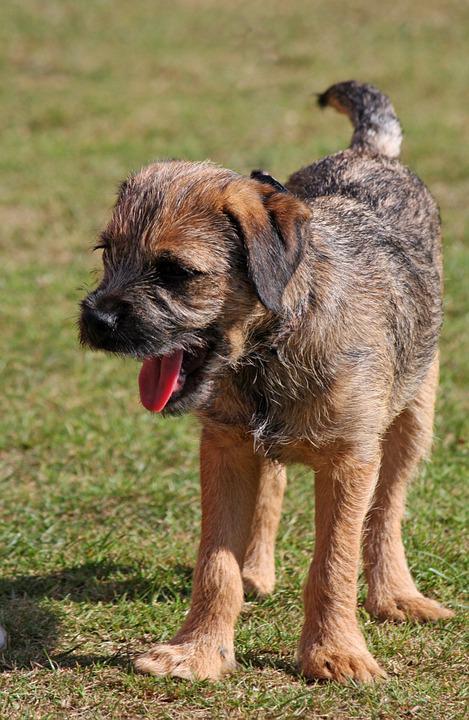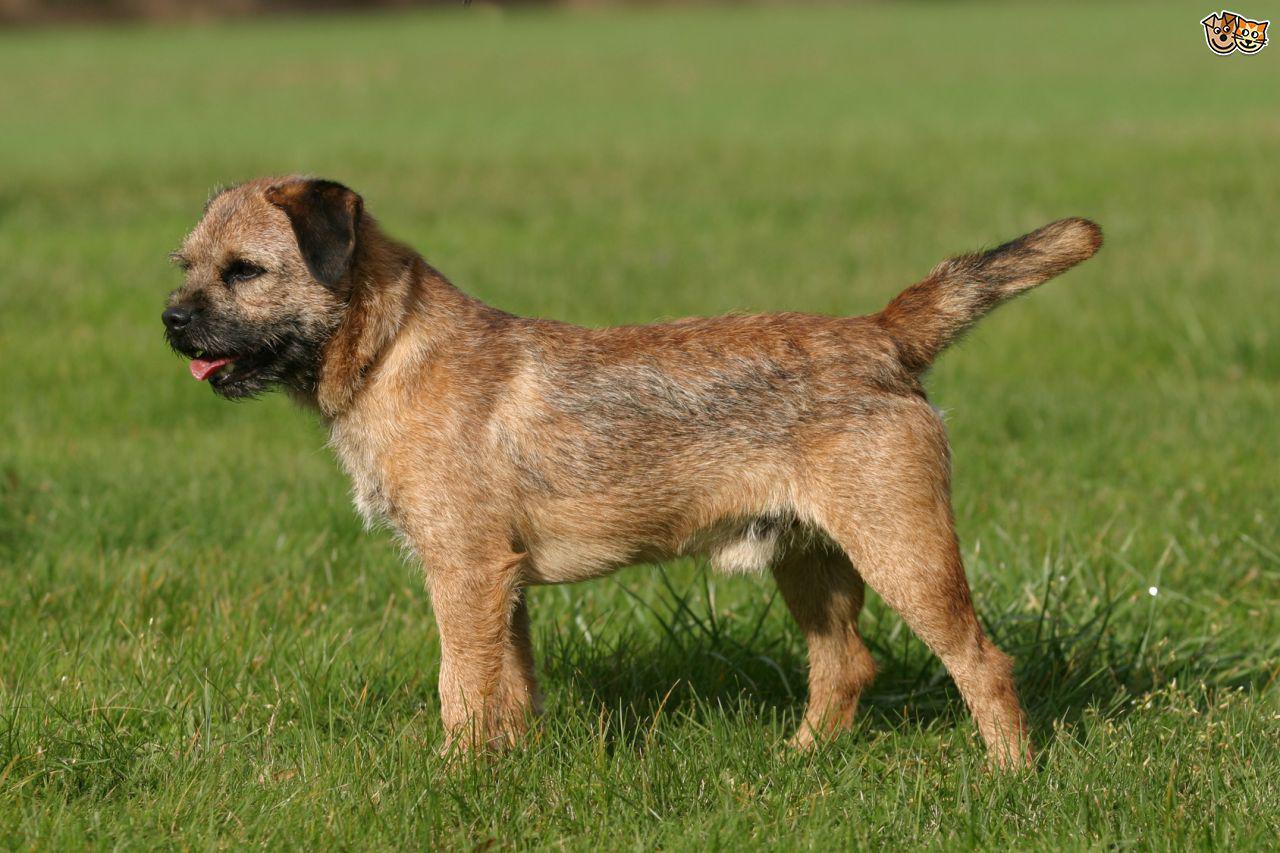The first image is the image on the left, the second image is the image on the right. Assess this claim about the two images: "Each image contains only one dog and one is sitting in one image and standing in the other image.". Correct or not? Answer yes or no. No. The first image is the image on the left, the second image is the image on the right. Considering the images on both sides, is "There is a dog in the right image, sitting down." valid? Answer yes or no. No. 